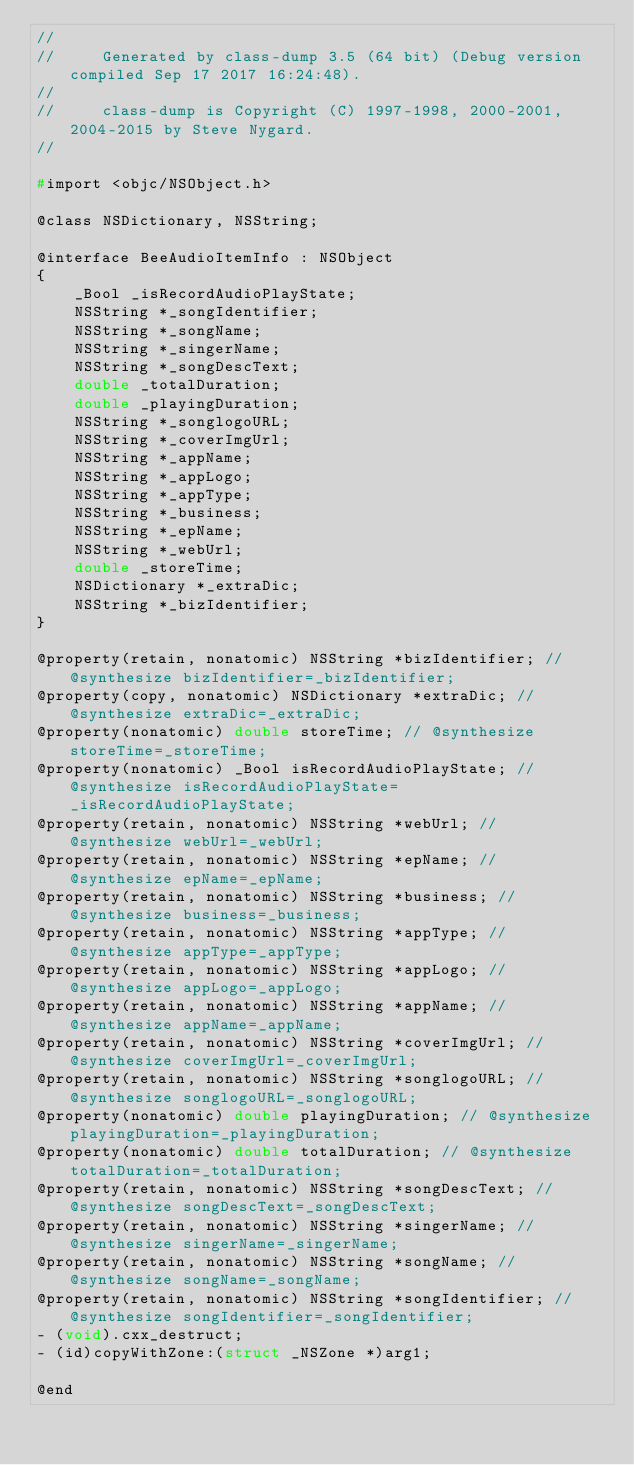<code> <loc_0><loc_0><loc_500><loc_500><_C_>//
//     Generated by class-dump 3.5 (64 bit) (Debug version compiled Sep 17 2017 16:24:48).
//
//     class-dump is Copyright (C) 1997-1998, 2000-2001, 2004-2015 by Steve Nygard.
//

#import <objc/NSObject.h>

@class NSDictionary, NSString;

@interface BeeAudioItemInfo : NSObject
{
    _Bool _isRecordAudioPlayState;
    NSString *_songIdentifier;
    NSString *_songName;
    NSString *_singerName;
    NSString *_songDescText;
    double _totalDuration;
    double _playingDuration;
    NSString *_songlogoURL;
    NSString *_coverImgUrl;
    NSString *_appName;
    NSString *_appLogo;
    NSString *_appType;
    NSString *_business;
    NSString *_epName;
    NSString *_webUrl;
    double _storeTime;
    NSDictionary *_extraDic;
    NSString *_bizIdentifier;
}

@property(retain, nonatomic) NSString *bizIdentifier; // @synthesize bizIdentifier=_bizIdentifier;
@property(copy, nonatomic) NSDictionary *extraDic; // @synthesize extraDic=_extraDic;
@property(nonatomic) double storeTime; // @synthesize storeTime=_storeTime;
@property(nonatomic) _Bool isRecordAudioPlayState; // @synthesize isRecordAudioPlayState=_isRecordAudioPlayState;
@property(retain, nonatomic) NSString *webUrl; // @synthesize webUrl=_webUrl;
@property(retain, nonatomic) NSString *epName; // @synthesize epName=_epName;
@property(retain, nonatomic) NSString *business; // @synthesize business=_business;
@property(retain, nonatomic) NSString *appType; // @synthesize appType=_appType;
@property(retain, nonatomic) NSString *appLogo; // @synthesize appLogo=_appLogo;
@property(retain, nonatomic) NSString *appName; // @synthesize appName=_appName;
@property(retain, nonatomic) NSString *coverImgUrl; // @synthesize coverImgUrl=_coverImgUrl;
@property(retain, nonatomic) NSString *songlogoURL; // @synthesize songlogoURL=_songlogoURL;
@property(nonatomic) double playingDuration; // @synthesize playingDuration=_playingDuration;
@property(nonatomic) double totalDuration; // @synthesize totalDuration=_totalDuration;
@property(retain, nonatomic) NSString *songDescText; // @synthesize songDescText=_songDescText;
@property(retain, nonatomic) NSString *singerName; // @synthesize singerName=_singerName;
@property(retain, nonatomic) NSString *songName; // @synthesize songName=_songName;
@property(retain, nonatomic) NSString *songIdentifier; // @synthesize songIdentifier=_songIdentifier;
- (void).cxx_destruct;
- (id)copyWithZone:(struct _NSZone *)arg1;

@end

</code> 